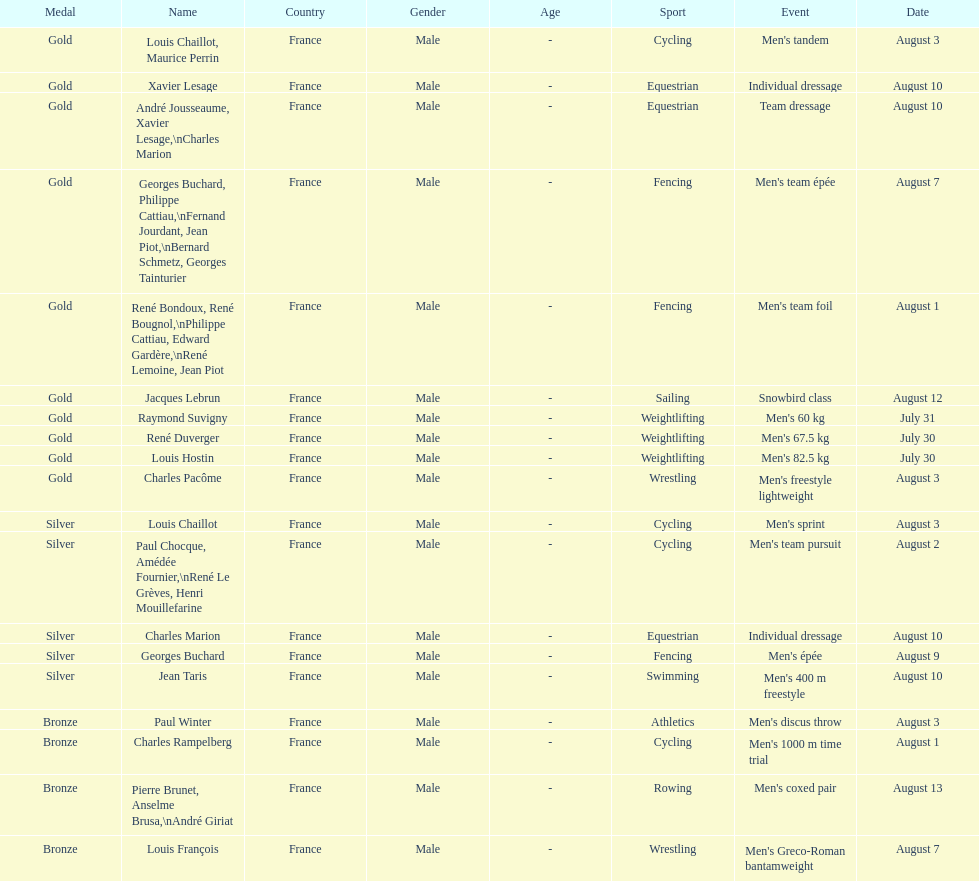Was there more gold medals won than silver? Yes. 